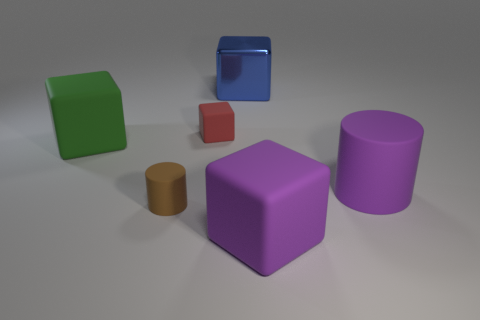Is there a pattern to the placement of the objects? While there is no clear pattern to the placement of the objects, they are arranged in what seems to be a random distribution across the plane. They are well-spaced and do not overlap, allowing each object to be clearly seen. The objects vary in size and color but are balanced in the space, creating a harmonious composition. 